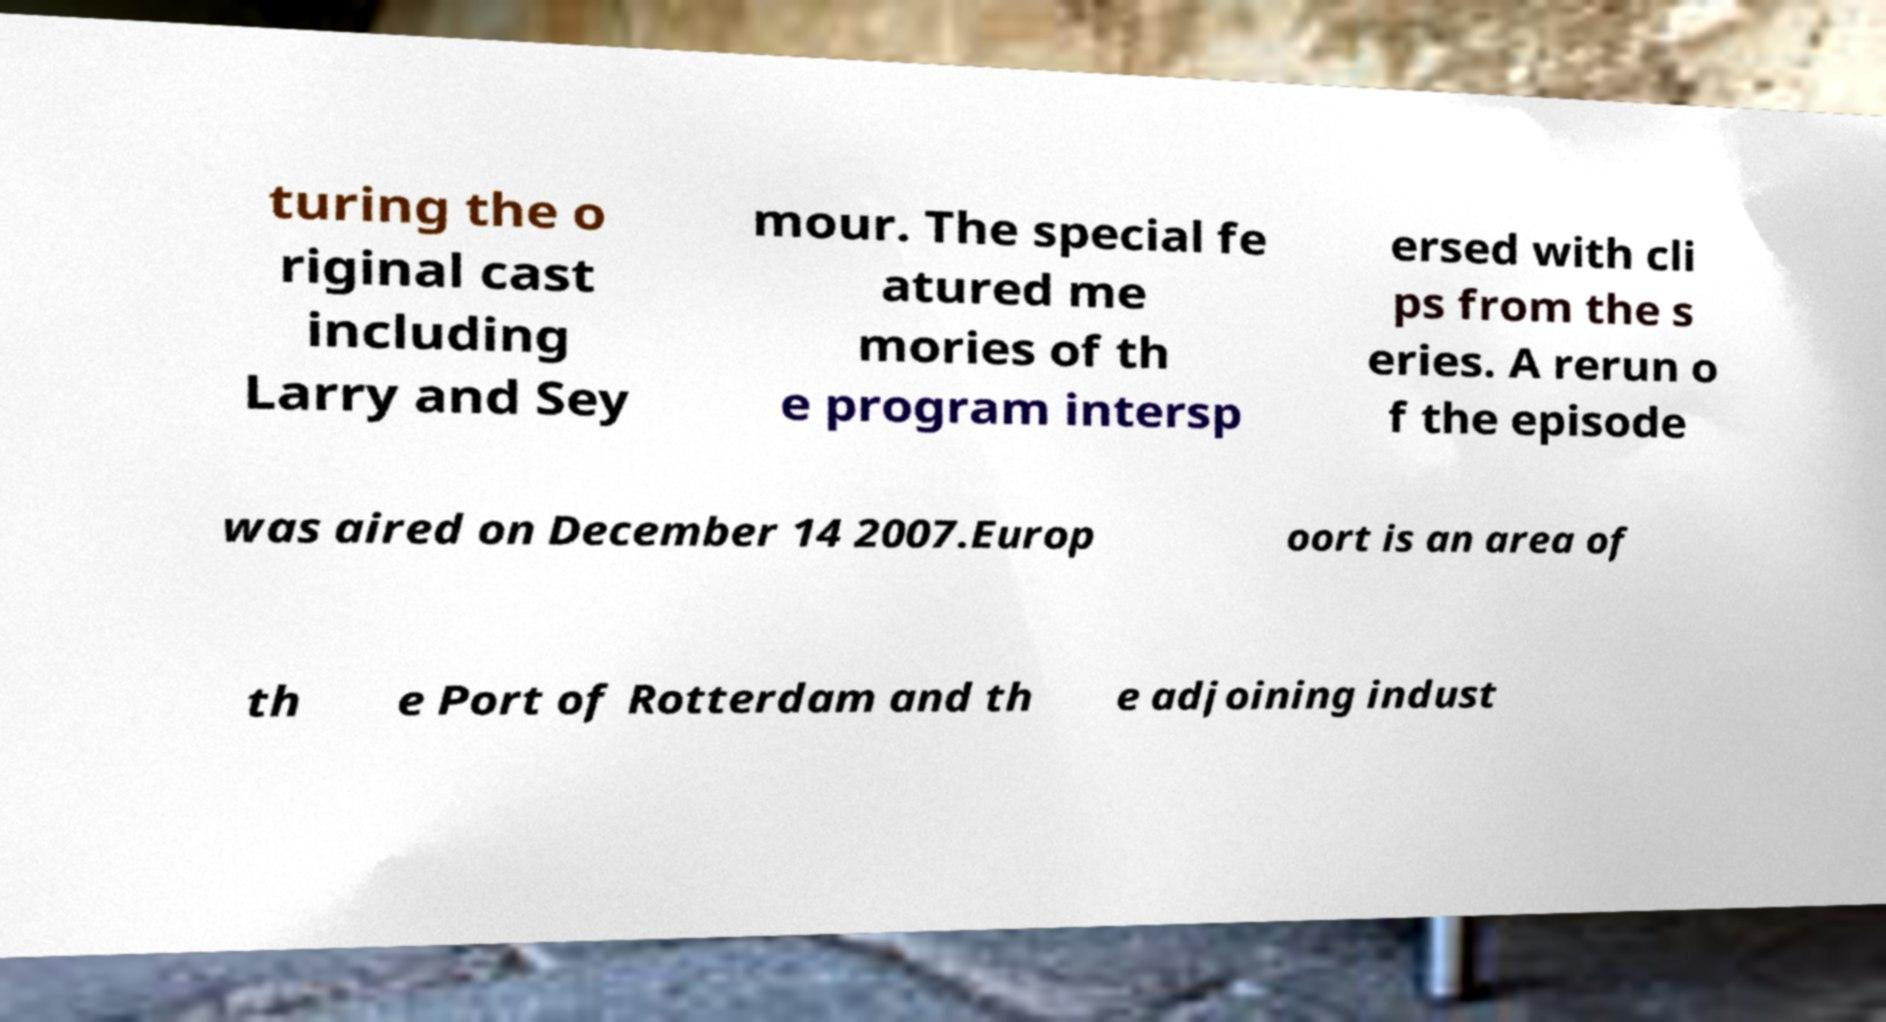There's text embedded in this image that I need extracted. Can you transcribe it verbatim? turing the o riginal cast including Larry and Sey mour. The special fe atured me mories of th e program intersp ersed with cli ps from the s eries. A rerun o f the episode was aired on December 14 2007.Europ oort is an area of th e Port of Rotterdam and th e adjoining indust 